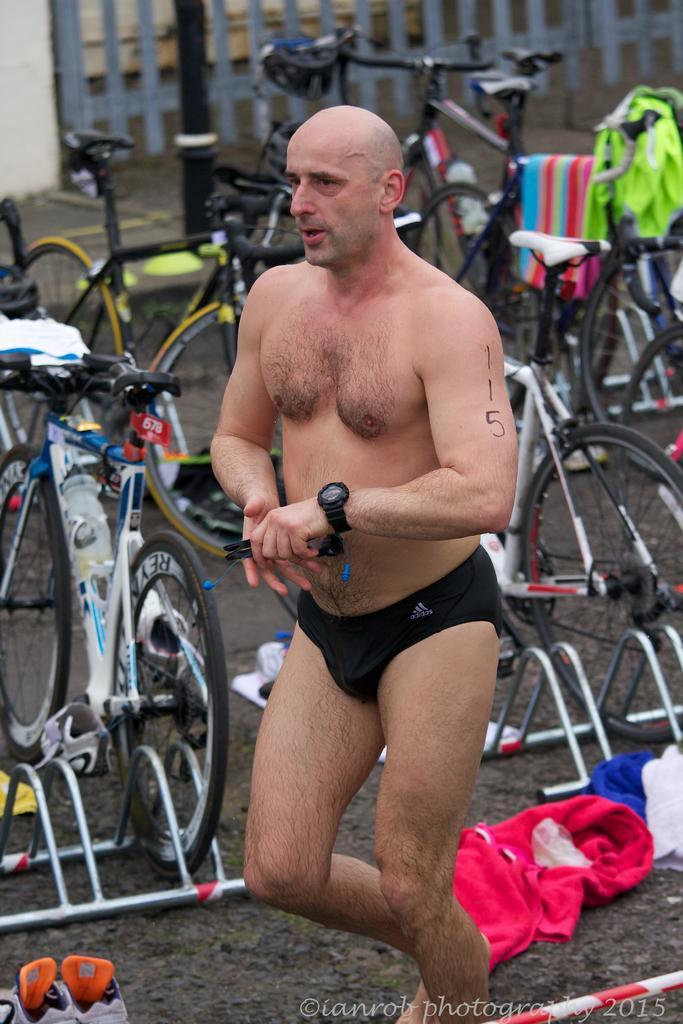Describe this image in one or two sentences. In this image I can see a person standing. Background I can see few bi-cycle and I can see few clothes on the bicycles. 